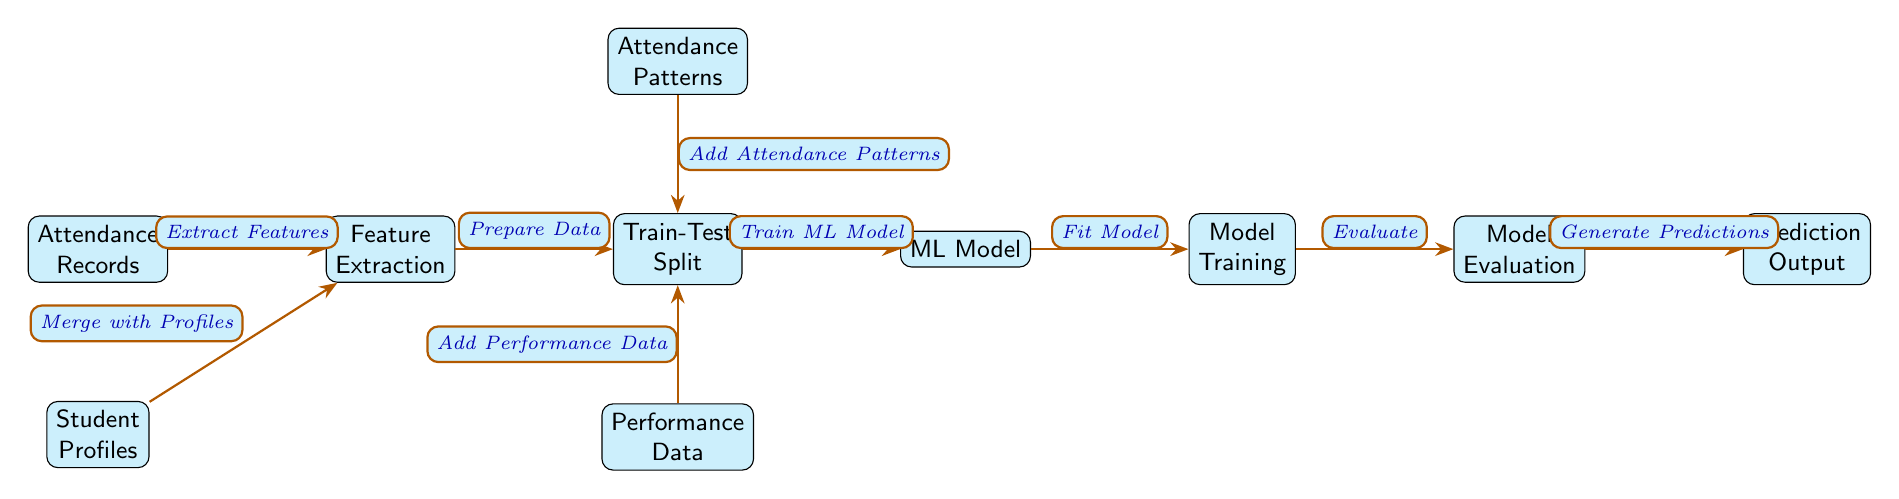What does the node to the left of the "Train-Test Split" represent? The node to the left of the "Train-Test Split" is "Feature Extraction," indicating the process where features from attendance data and student profiles are extracted before data preparation.
Answer: Feature Extraction How many nodes are there in the diagram? Counting each distinct labeled box in the diagram results in a total of nine nodes, including "Attendance Records" and "Prediction Output."
Answer: Nine What process is done after "Model Training"? After "Model Training," the next process is "Model Evaluation," which assesses the performance of the trained model on test data.
Answer: Model Evaluation What type of data is added to the "Train-Test Split" from above? The data added from above is "Attendance Patterns," representing patterns derived from the attendance records that contribute to preparing the data for modeling.
Answer: Attendance Patterns Which node provides the final output of the process? The final output of the process is provided by the "Prediction Output," which indicates the result of the predictions made by the machine learning model.
Answer: Prediction Output What is the first step in this machine learning flow? The first step in this flow is "Attendance Records," which sets the baseline for further processing to predict student absence.
Answer: Attendance Records What is the relationship between "Feature Extraction" and "Train-Test Split"? "Feature Extraction" contributes to the "Train-Test Split" by preparing the data extracted from attendance records and student profiles for further modeling.
Answer: Prepare Data What does the "ML Model" node signify? The "ML Model" node signifies the stage where the machine learning algorithms are applied to the prepared data to learn patterns for predicting absences.
Answer: ML Model 